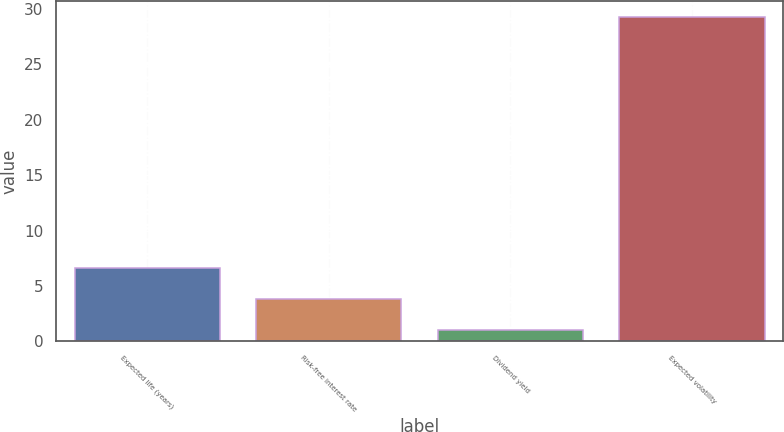<chart> <loc_0><loc_0><loc_500><loc_500><bar_chart><fcel>Expected life (years)<fcel>Risk-free interest rate<fcel>Dividend yield<fcel>Expected volatility<nl><fcel>6.66<fcel>3.83<fcel>1<fcel>29.3<nl></chart> 